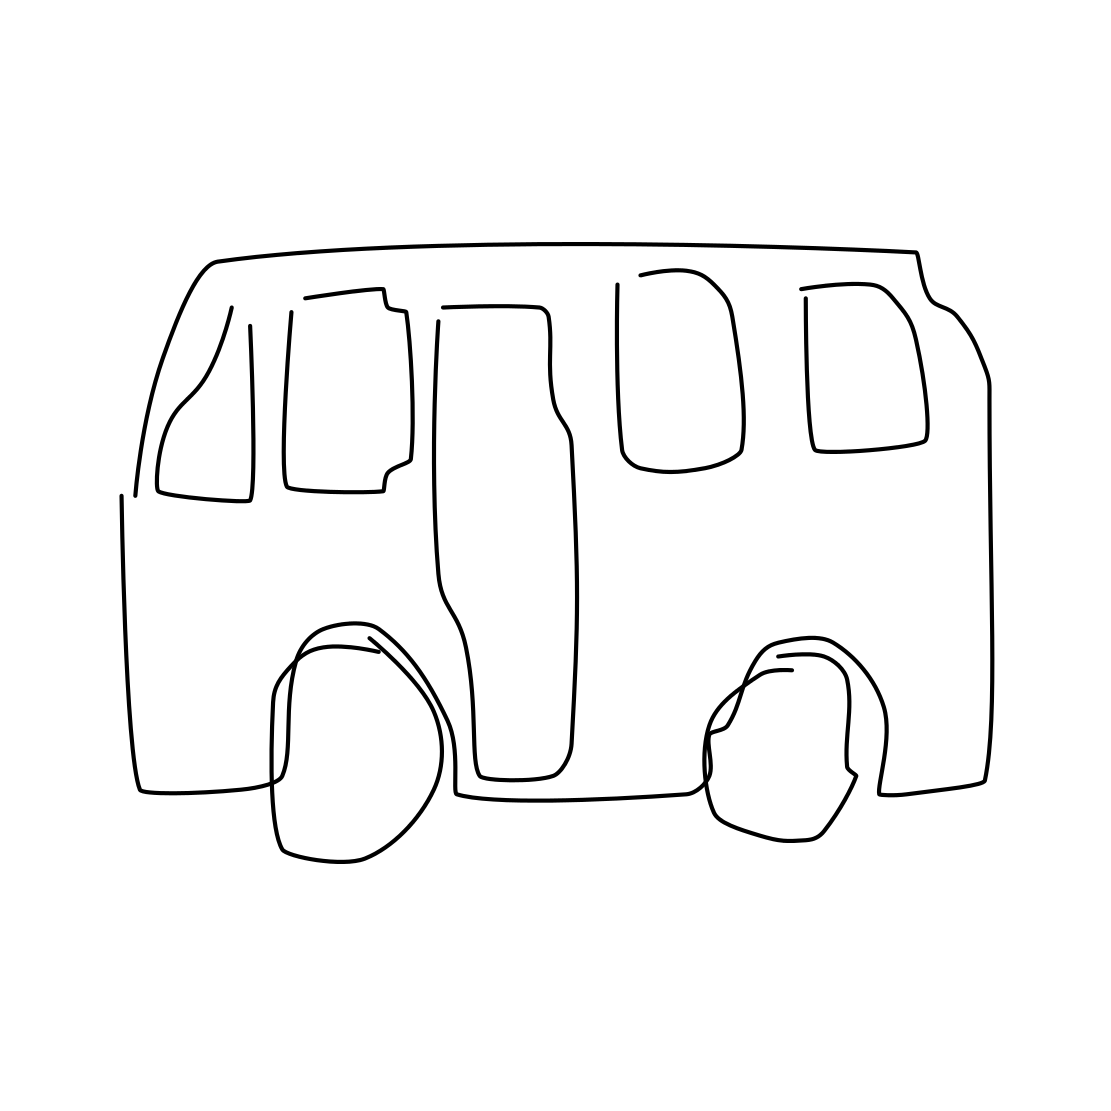Is there anything missing in this vehicle that you would expect in a more detailed drawing? In a more detailed drawing of a vehicle, one might expect to see clear indications of door handles, headlamps, tail lights, mirrors, and more defined wheels. Additionally, details such as the grille, brand emblems, and textural elements might be included to enhance realism. 